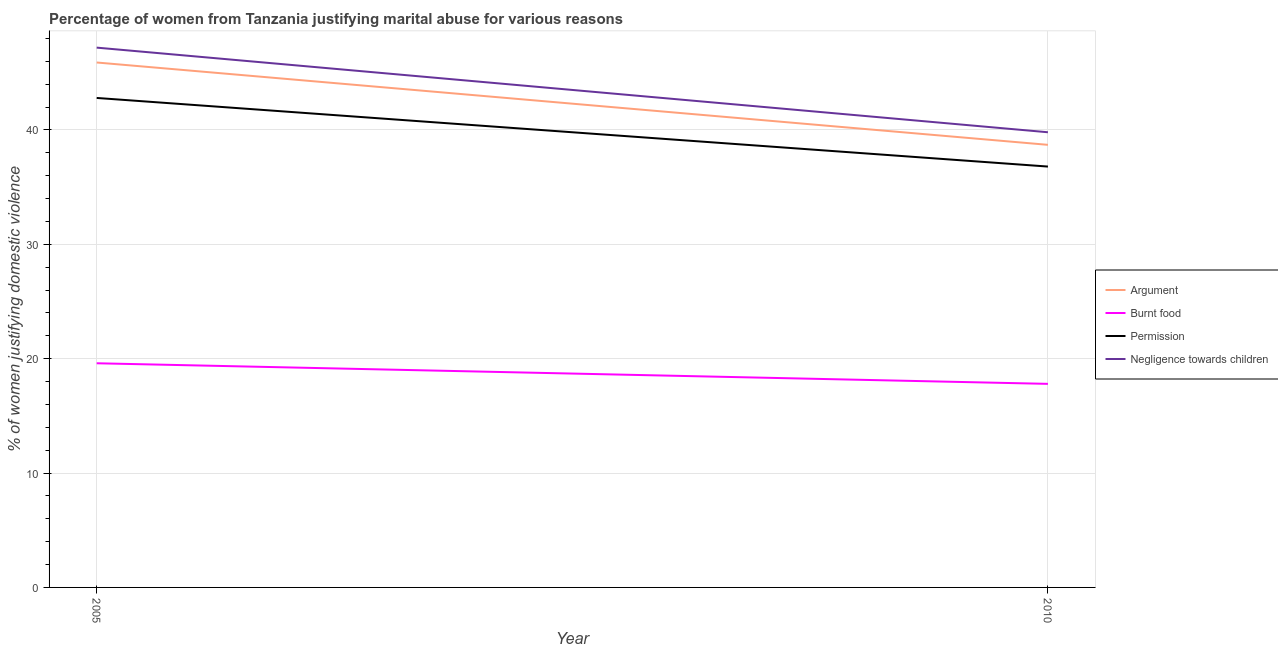How many different coloured lines are there?
Your answer should be compact. 4. Is the number of lines equal to the number of legend labels?
Offer a very short reply. Yes. Across all years, what is the maximum percentage of women justifying abuse for going without permission?
Make the answer very short. 42.8. Across all years, what is the minimum percentage of women justifying abuse in the case of an argument?
Your answer should be very brief. 38.7. In which year was the percentage of women justifying abuse for burning food maximum?
Provide a short and direct response. 2005. What is the total percentage of women justifying abuse in the case of an argument in the graph?
Ensure brevity in your answer.  84.6. What is the difference between the percentage of women justifying abuse in the case of an argument in 2005 and that in 2010?
Your answer should be compact. 7.2. What is the difference between the percentage of women justifying abuse for going without permission in 2005 and the percentage of women justifying abuse for burning food in 2010?
Your response must be concise. 25. What is the average percentage of women justifying abuse for going without permission per year?
Your response must be concise. 39.8. In the year 2010, what is the difference between the percentage of women justifying abuse for showing negligence towards children and percentage of women justifying abuse for burning food?
Your answer should be very brief. 22. In how many years, is the percentage of women justifying abuse for showing negligence towards children greater than 12 %?
Provide a succinct answer. 2. What is the ratio of the percentage of women justifying abuse for showing negligence towards children in 2005 to that in 2010?
Offer a very short reply. 1.19. In how many years, is the percentage of women justifying abuse for burning food greater than the average percentage of women justifying abuse for burning food taken over all years?
Offer a terse response. 1. Is it the case that in every year, the sum of the percentage of women justifying abuse in the case of an argument and percentage of women justifying abuse for burning food is greater than the percentage of women justifying abuse for going without permission?
Provide a short and direct response. Yes. Does the percentage of women justifying abuse for going without permission monotonically increase over the years?
Give a very brief answer. No. How many lines are there?
Give a very brief answer. 4. Are the values on the major ticks of Y-axis written in scientific E-notation?
Give a very brief answer. No. Does the graph contain grids?
Keep it short and to the point. Yes. How are the legend labels stacked?
Your answer should be very brief. Vertical. What is the title of the graph?
Offer a very short reply. Percentage of women from Tanzania justifying marital abuse for various reasons. What is the label or title of the Y-axis?
Your response must be concise. % of women justifying domestic violence. What is the % of women justifying domestic violence of Argument in 2005?
Provide a succinct answer. 45.9. What is the % of women justifying domestic violence of Burnt food in 2005?
Provide a succinct answer. 19.6. What is the % of women justifying domestic violence of Permission in 2005?
Offer a terse response. 42.8. What is the % of women justifying domestic violence in Negligence towards children in 2005?
Your answer should be very brief. 47.2. What is the % of women justifying domestic violence of Argument in 2010?
Keep it short and to the point. 38.7. What is the % of women justifying domestic violence in Burnt food in 2010?
Offer a very short reply. 17.8. What is the % of women justifying domestic violence of Permission in 2010?
Offer a terse response. 36.8. What is the % of women justifying domestic violence of Negligence towards children in 2010?
Provide a short and direct response. 39.8. Across all years, what is the maximum % of women justifying domestic violence in Argument?
Ensure brevity in your answer.  45.9. Across all years, what is the maximum % of women justifying domestic violence in Burnt food?
Provide a succinct answer. 19.6. Across all years, what is the maximum % of women justifying domestic violence of Permission?
Ensure brevity in your answer.  42.8. Across all years, what is the maximum % of women justifying domestic violence in Negligence towards children?
Offer a terse response. 47.2. Across all years, what is the minimum % of women justifying domestic violence of Argument?
Offer a terse response. 38.7. Across all years, what is the minimum % of women justifying domestic violence of Permission?
Make the answer very short. 36.8. Across all years, what is the minimum % of women justifying domestic violence in Negligence towards children?
Ensure brevity in your answer.  39.8. What is the total % of women justifying domestic violence of Argument in the graph?
Your answer should be very brief. 84.6. What is the total % of women justifying domestic violence of Burnt food in the graph?
Your answer should be very brief. 37.4. What is the total % of women justifying domestic violence of Permission in the graph?
Provide a succinct answer. 79.6. What is the total % of women justifying domestic violence in Negligence towards children in the graph?
Offer a terse response. 87. What is the difference between the % of women justifying domestic violence in Argument in 2005 and that in 2010?
Make the answer very short. 7.2. What is the difference between the % of women justifying domestic violence of Burnt food in 2005 and that in 2010?
Make the answer very short. 1.8. What is the difference between the % of women justifying domestic violence in Negligence towards children in 2005 and that in 2010?
Ensure brevity in your answer.  7.4. What is the difference between the % of women justifying domestic violence of Argument in 2005 and the % of women justifying domestic violence of Burnt food in 2010?
Keep it short and to the point. 28.1. What is the difference between the % of women justifying domestic violence of Argument in 2005 and the % of women justifying domestic violence of Permission in 2010?
Provide a short and direct response. 9.1. What is the difference between the % of women justifying domestic violence of Burnt food in 2005 and the % of women justifying domestic violence of Permission in 2010?
Keep it short and to the point. -17.2. What is the difference between the % of women justifying domestic violence in Burnt food in 2005 and the % of women justifying domestic violence in Negligence towards children in 2010?
Keep it short and to the point. -20.2. What is the difference between the % of women justifying domestic violence of Permission in 2005 and the % of women justifying domestic violence of Negligence towards children in 2010?
Make the answer very short. 3. What is the average % of women justifying domestic violence of Argument per year?
Your answer should be compact. 42.3. What is the average % of women justifying domestic violence in Permission per year?
Give a very brief answer. 39.8. What is the average % of women justifying domestic violence in Negligence towards children per year?
Your answer should be compact. 43.5. In the year 2005, what is the difference between the % of women justifying domestic violence of Argument and % of women justifying domestic violence of Burnt food?
Your answer should be compact. 26.3. In the year 2005, what is the difference between the % of women justifying domestic violence in Argument and % of women justifying domestic violence in Negligence towards children?
Make the answer very short. -1.3. In the year 2005, what is the difference between the % of women justifying domestic violence of Burnt food and % of women justifying domestic violence of Permission?
Give a very brief answer. -23.2. In the year 2005, what is the difference between the % of women justifying domestic violence in Burnt food and % of women justifying domestic violence in Negligence towards children?
Provide a short and direct response. -27.6. In the year 2010, what is the difference between the % of women justifying domestic violence in Argument and % of women justifying domestic violence in Burnt food?
Make the answer very short. 20.9. In the year 2010, what is the difference between the % of women justifying domestic violence of Burnt food and % of women justifying domestic violence of Negligence towards children?
Ensure brevity in your answer.  -22. What is the ratio of the % of women justifying domestic violence in Argument in 2005 to that in 2010?
Offer a very short reply. 1.19. What is the ratio of the % of women justifying domestic violence of Burnt food in 2005 to that in 2010?
Provide a short and direct response. 1.1. What is the ratio of the % of women justifying domestic violence in Permission in 2005 to that in 2010?
Your answer should be compact. 1.16. What is the ratio of the % of women justifying domestic violence in Negligence towards children in 2005 to that in 2010?
Your answer should be compact. 1.19. What is the difference between the highest and the second highest % of women justifying domestic violence in Argument?
Make the answer very short. 7.2. What is the difference between the highest and the second highest % of women justifying domestic violence in Burnt food?
Your response must be concise. 1.8. What is the difference between the highest and the second highest % of women justifying domestic violence of Permission?
Offer a terse response. 6. What is the difference between the highest and the second highest % of women justifying domestic violence of Negligence towards children?
Make the answer very short. 7.4. 